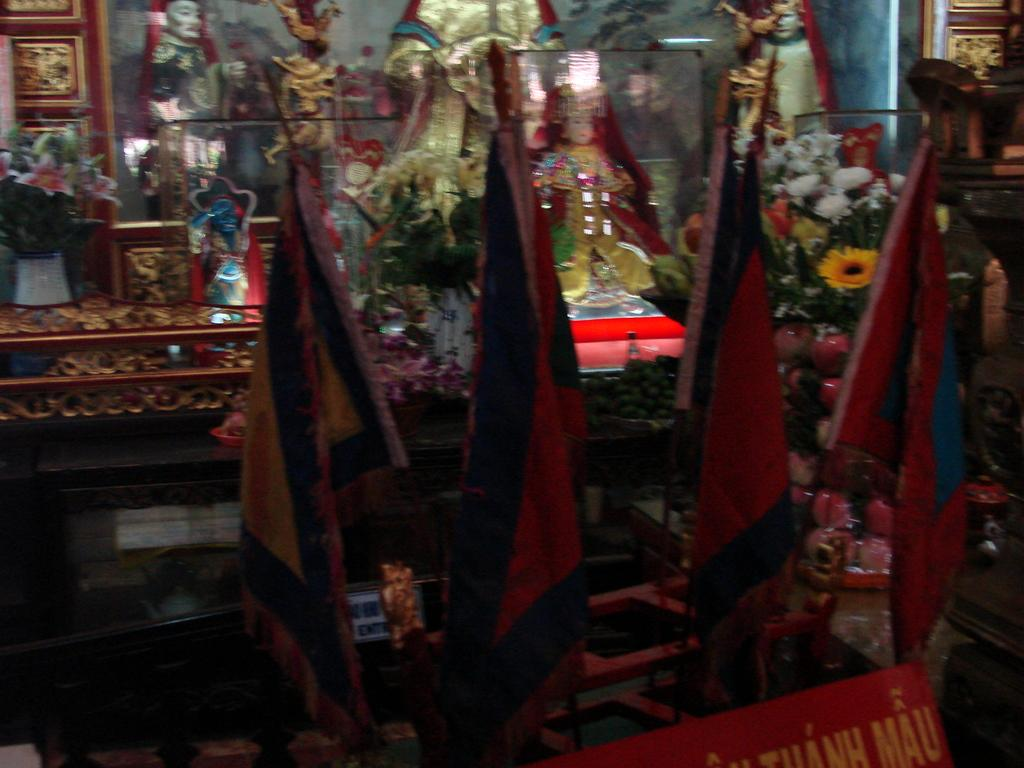What type of objects can be seen in the image? There are idols in the image. What else can be found in the image besides idols? There are plants and flowers in the image. Can you describe the plants and flowers in the image? Unfortunately, the facts provided do not specify the type of plants or flowers in the image. Are there any other objects or features in the image besides the idols, plants, and flowers? Yes, there are other unspecified things around in the image. What type of quill is being used to write on the idol in the image? There is no quill present in the image, and the idols are not being written on. 